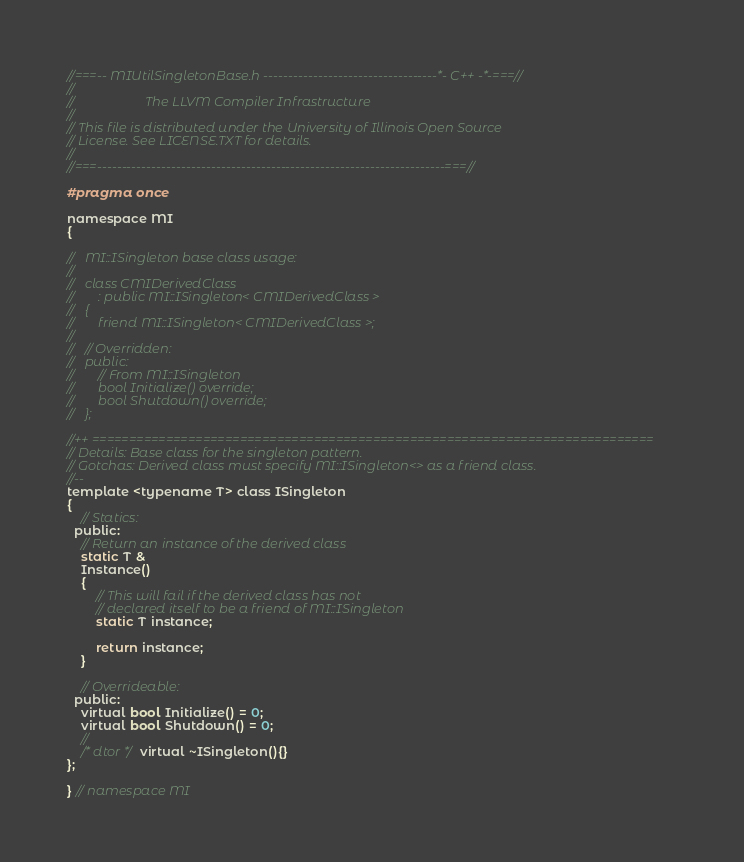<code> <loc_0><loc_0><loc_500><loc_500><_C_>//===-- MIUtilSingletonBase.h -----------------------------------*- C++ -*-===//
//
//                     The LLVM Compiler Infrastructure
//
// This file is distributed under the University of Illinois Open Source
// License. See LICENSE.TXT for details.
//
//===----------------------------------------------------------------------===//

#pragma once

namespace MI
{

//   MI::ISingleton base class usage:
//
//   class CMIDerivedClass
//       : public MI::ISingleton< CMIDerivedClass >
//   {
//       friend MI::ISingleton< CMIDerivedClass >;
//
//   // Overridden:
//   public:
//       // From MI::ISingleton
//       bool Initialize() override;
//       bool Shutdown() override;
//   };

//++ ============================================================================
// Details: Base class for the singleton pattern.
// Gotchas: Derived class must specify MI::ISingleton<> as a friend class.
//--
template <typename T> class ISingleton
{
    // Statics:
  public:
    // Return an instance of the derived class
    static T &
    Instance()
    {
        // This will fail if the derived class has not
        // declared itself to be a friend of MI::ISingleton
        static T instance;

        return instance;
    }

    // Overrideable:
  public:
    virtual bool Initialize() = 0;
    virtual bool Shutdown() = 0;
    //
    /* dtor */ virtual ~ISingleton(){}
};

} // namespace MI
</code> 